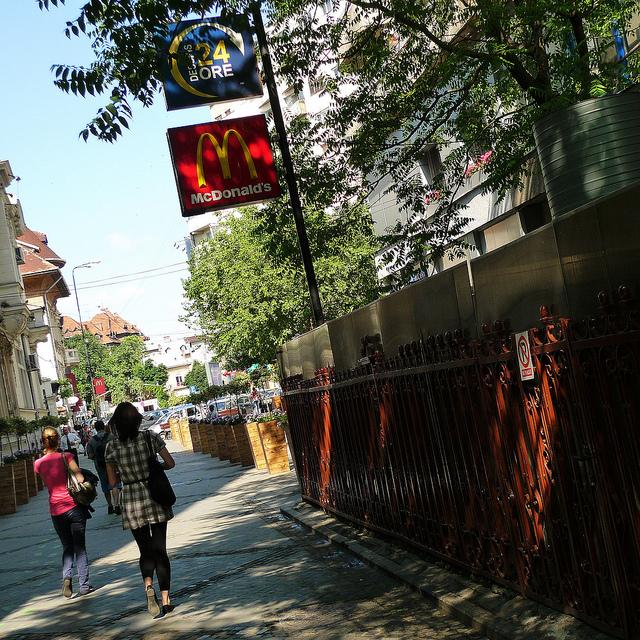The black and white sign next to the plant suggests that this is part of what kind of display?
Keep it brief. Wildlife. What fast food restaurant is there a sign for?
Write a very short answer. Mcdonald's. Is this a sunny day?
Keep it brief. Yes. Which woman is wearing plaid?
Keep it brief. One on right. 